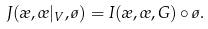<formula> <loc_0><loc_0><loc_500><loc_500>J ( \rho , \sigma | _ { V } , \tau ) = I ( \rho , \sigma , G ) \circ \tau .</formula> 